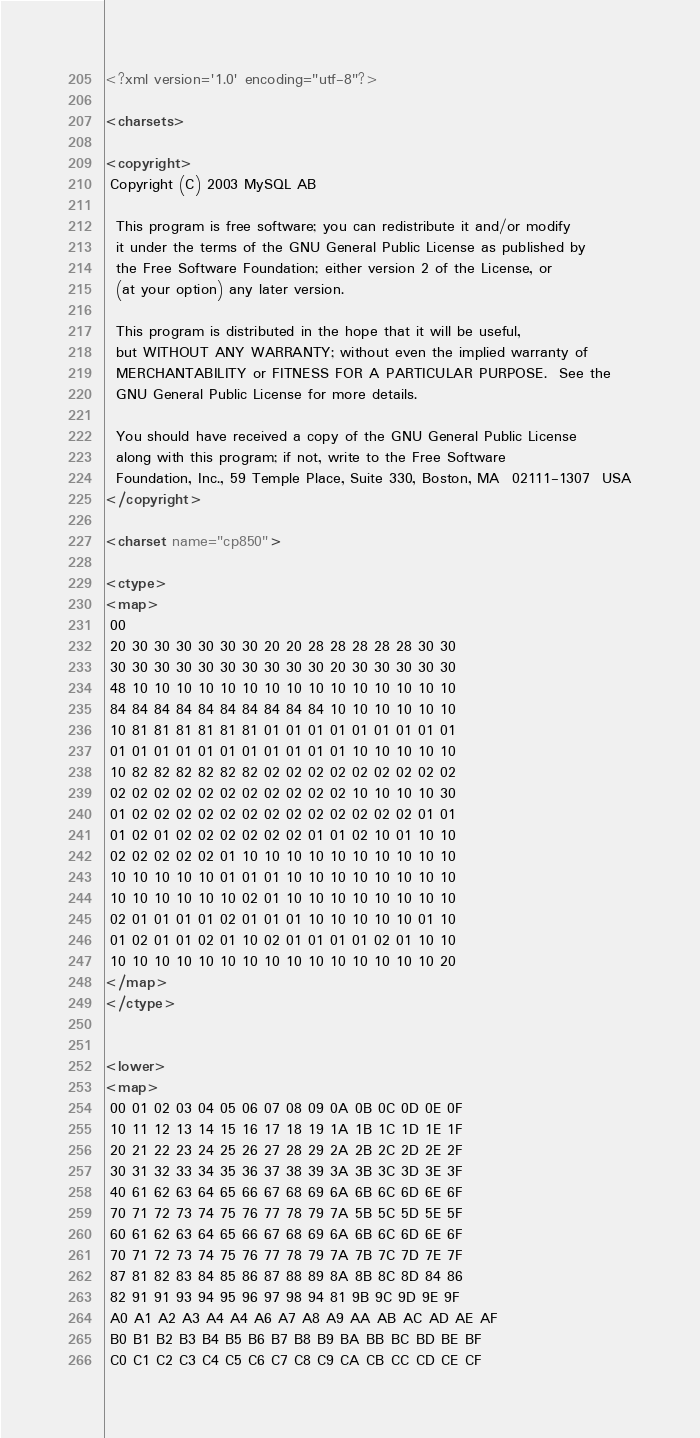Convert code to text. <code><loc_0><loc_0><loc_500><loc_500><_XML_><?xml version='1.0' encoding="utf-8"?>

<charsets>

<copyright>
 Copyright (C) 2003 MySQL AB

  This program is free software; you can redistribute it and/or modify
  it under the terms of the GNU General Public License as published by
  the Free Software Foundation; either version 2 of the License, or
  (at your option) any later version.

  This program is distributed in the hope that it will be useful,
  but WITHOUT ANY WARRANTY; without even the implied warranty of
  MERCHANTABILITY or FITNESS FOR A PARTICULAR PURPOSE.  See the
  GNU General Public License for more details.

  You should have received a copy of the GNU General Public License
  along with this program; if not, write to the Free Software
  Foundation, Inc., 59 Temple Place, Suite 330, Boston, MA  02111-1307  USA
</copyright>

<charset name="cp850">

<ctype>
<map>
 00
 20 30 30 30 30 30 30 20 20 28 28 28 28 28 30 30
 30 30 30 30 30 30 30 30 30 30 20 30 30 30 30 30
 48 10 10 10 10 10 10 10 10 10 10 10 10 10 10 10
 84 84 84 84 84 84 84 84 84 84 10 10 10 10 10 10
 10 81 81 81 81 81 81 01 01 01 01 01 01 01 01 01
 01 01 01 01 01 01 01 01 01 01 01 10 10 10 10 10
 10 82 82 82 82 82 82 02 02 02 02 02 02 02 02 02
 02 02 02 02 02 02 02 02 02 02 02 10 10 10 10 30
 01 02 02 02 02 02 02 02 02 02 02 02 02 02 01 01
 01 02 01 02 02 02 02 02 02 01 01 02 10 01 10 10
 02 02 02 02 02 01 10 10 10 10 10 10 10 10 10 10
 10 10 10 10 10 01 01 01 10 10 10 10 10 10 10 10
 10 10 10 10 10 10 02 01 10 10 10 10 10 10 10 10
 02 01 01 01 01 02 01 01 01 10 10 10 10 10 01 10
 01 02 01 01 02 01 10 02 01 01 01 01 02 01 10 10
 10 10 10 10 10 10 10 10 10 10 10 10 10 10 10 20
</map>
</ctype>


<lower>
<map>
 00 01 02 03 04 05 06 07 08 09 0A 0B 0C 0D 0E 0F
 10 11 12 13 14 15 16 17 18 19 1A 1B 1C 1D 1E 1F
 20 21 22 23 24 25 26 27 28 29 2A 2B 2C 2D 2E 2F
 30 31 32 33 34 35 36 37 38 39 3A 3B 3C 3D 3E 3F
 40 61 62 63 64 65 66 67 68 69 6A 6B 6C 6D 6E 6F
 70 71 72 73 74 75 76 77 78 79 7A 5B 5C 5D 5E 5F
 60 61 62 63 64 65 66 67 68 69 6A 6B 6C 6D 6E 6F
 70 71 72 73 74 75 76 77 78 79 7A 7B 7C 7D 7E 7F
 87 81 82 83 84 85 86 87 88 89 8A 8B 8C 8D 84 86
 82 91 91 93 94 95 96 97 98 94 81 9B 9C 9D 9E 9F
 A0 A1 A2 A3 A4 A4 A6 A7 A8 A9 AA AB AC AD AE AF
 B0 B1 B2 B3 B4 B5 B6 B7 B8 B9 BA BB BC BD BE BF
 C0 C1 C2 C3 C4 C5 C6 C7 C8 C9 CA CB CC CD CE CF</code> 